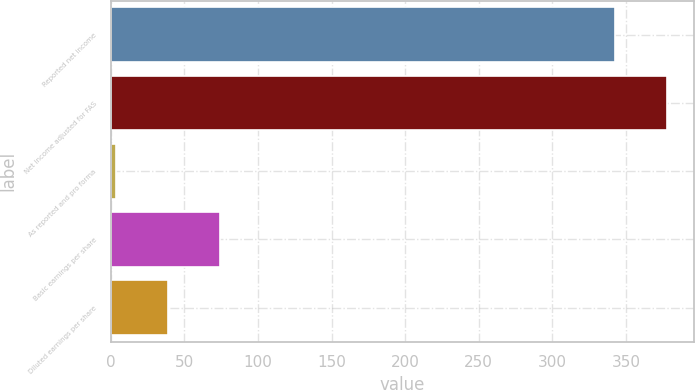Convert chart. <chart><loc_0><loc_0><loc_500><loc_500><bar_chart><fcel>Reported net income<fcel>Net income adjusted for FAS<fcel>As reported and pro forma<fcel>Basic earnings per share<fcel>Diluted earnings per share<nl><fcel>342.2<fcel>377.6<fcel>3.31<fcel>74.11<fcel>38.71<nl></chart> 